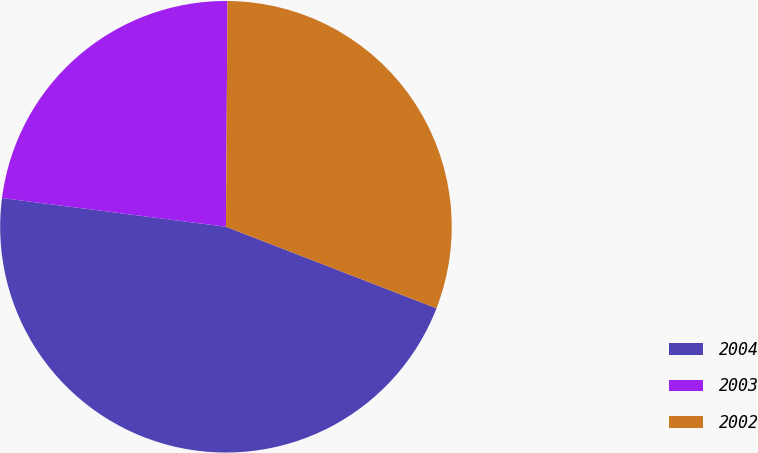<chart> <loc_0><loc_0><loc_500><loc_500><pie_chart><fcel>2004<fcel>2003<fcel>2002<nl><fcel>46.15%<fcel>23.08%<fcel>30.77%<nl></chart> 